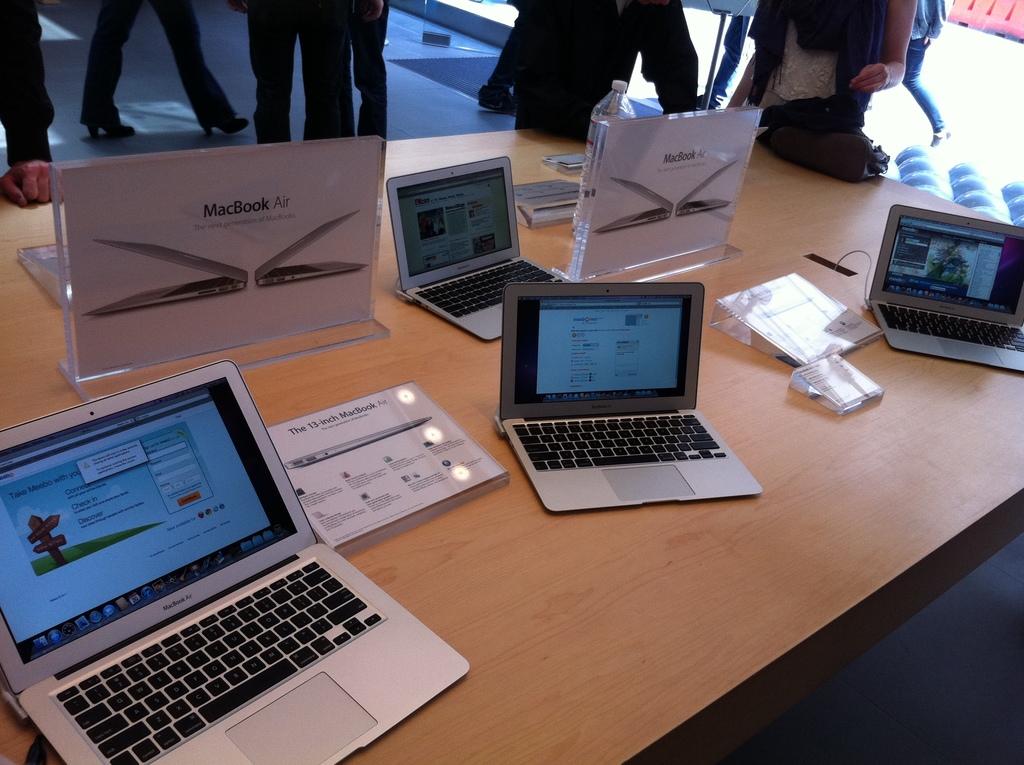What brand of macs are those?
Offer a terse response. Macbook air. 